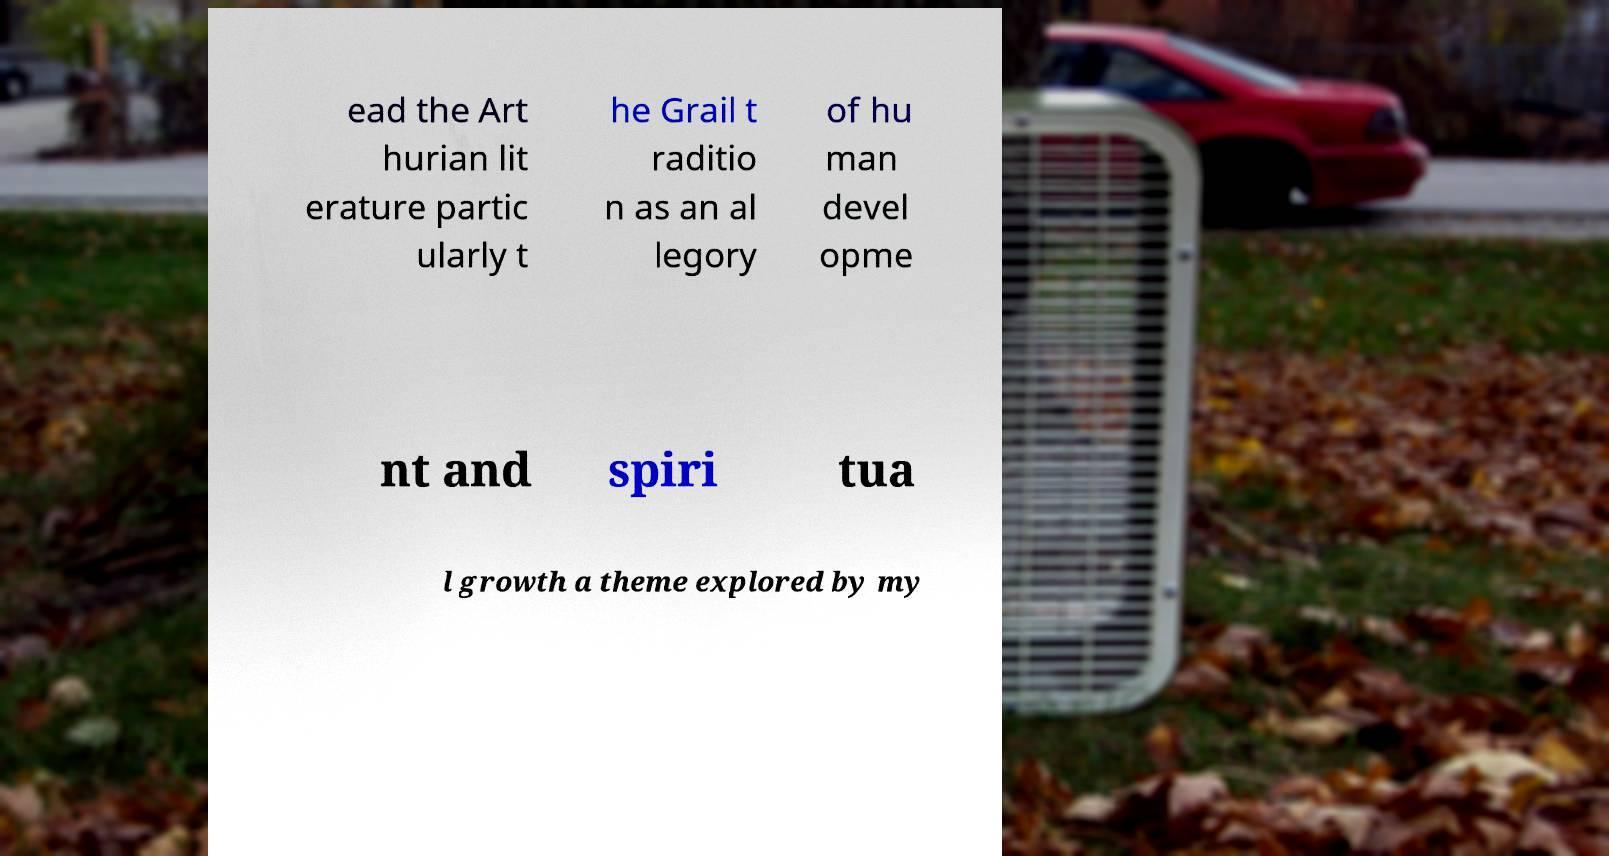Can you read and provide the text displayed in the image?This photo seems to have some interesting text. Can you extract and type it out for me? ead the Art hurian lit erature partic ularly t he Grail t raditio n as an al legory of hu man devel opme nt and spiri tua l growth a theme explored by my 